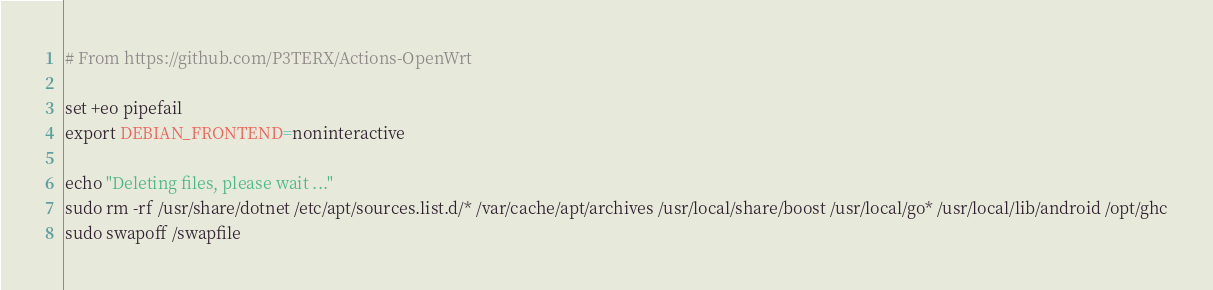<code> <loc_0><loc_0><loc_500><loc_500><_Bash_># From https://github.com/P3TERX/Actions-OpenWrt

set +eo pipefail
export DEBIAN_FRONTEND=noninteractive

echo "Deleting files, please wait ..."
sudo rm -rf /usr/share/dotnet /etc/apt/sources.list.d/* /var/cache/apt/archives /usr/local/share/boost /usr/local/go* /usr/local/lib/android /opt/ghc
sudo swapoff /swapfile</code> 